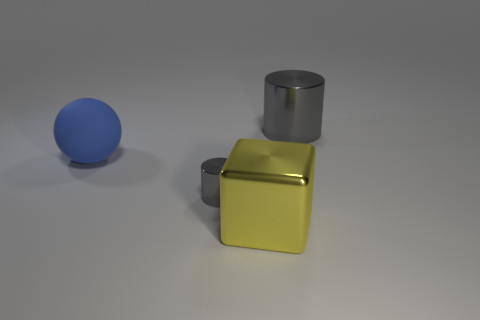Is the tiny metallic cylinder the same color as the large shiny cylinder?
Your response must be concise. Yes. What number of other things are there of the same size as the blue matte object?
Your answer should be very brief. 2. There is a shiny cylinder that is behind the large blue object; what size is it?
Keep it short and to the point. Large. The cylinder in front of the gray shiny thing that is to the right of the large object in front of the large ball is made of what material?
Your answer should be very brief. Metal. Is the shape of the yellow object the same as the big gray object?
Offer a very short reply. No. How many rubber objects are blue things or tiny cyan blocks?
Provide a succinct answer. 1. How many tiny metallic cylinders are there?
Provide a succinct answer. 1. The ball that is the same size as the yellow shiny object is what color?
Offer a terse response. Blue. Is the ball the same size as the yellow cube?
Offer a very short reply. Yes. What is the shape of the big object that is the same color as the tiny object?
Keep it short and to the point. Cylinder. 